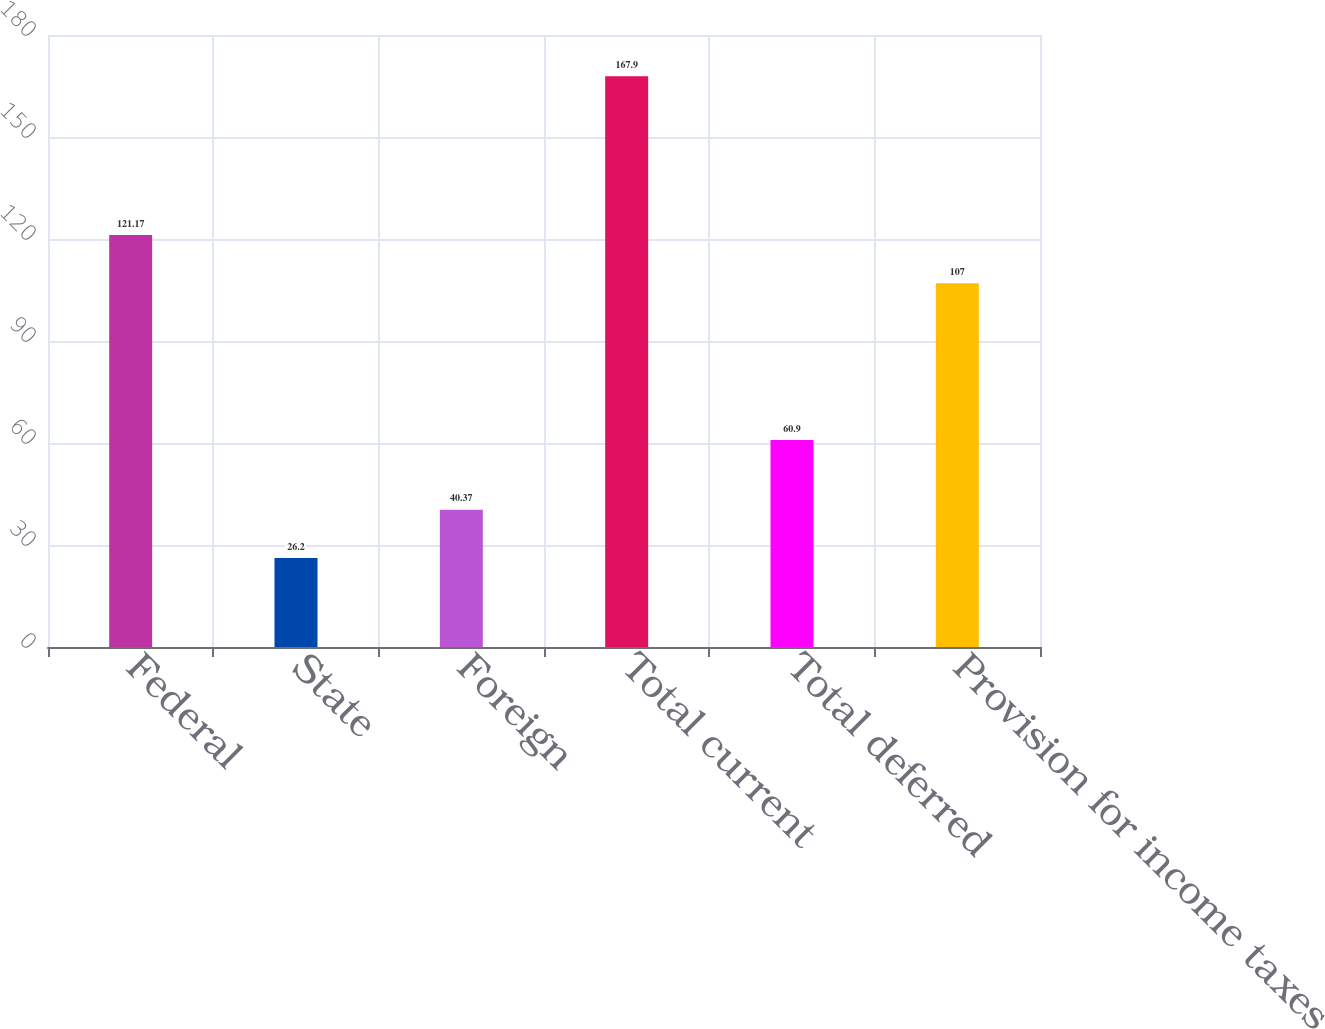<chart> <loc_0><loc_0><loc_500><loc_500><bar_chart><fcel>Federal<fcel>State<fcel>Foreign<fcel>Total current<fcel>Total deferred<fcel>Provision for income taxes<nl><fcel>121.17<fcel>26.2<fcel>40.37<fcel>167.9<fcel>60.9<fcel>107<nl></chart> 